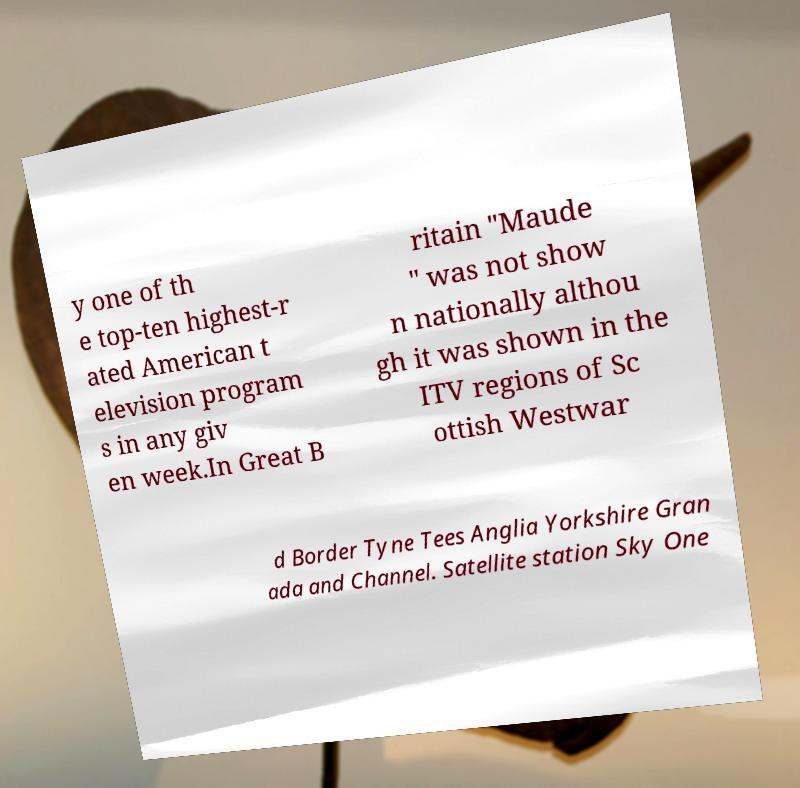For documentation purposes, I need the text within this image transcribed. Could you provide that? y one of th e top-ten highest-r ated American t elevision program s in any giv en week.In Great B ritain "Maude " was not show n nationally althou gh it was shown in the ITV regions of Sc ottish Westwar d Border Tyne Tees Anglia Yorkshire Gran ada and Channel. Satellite station Sky One 